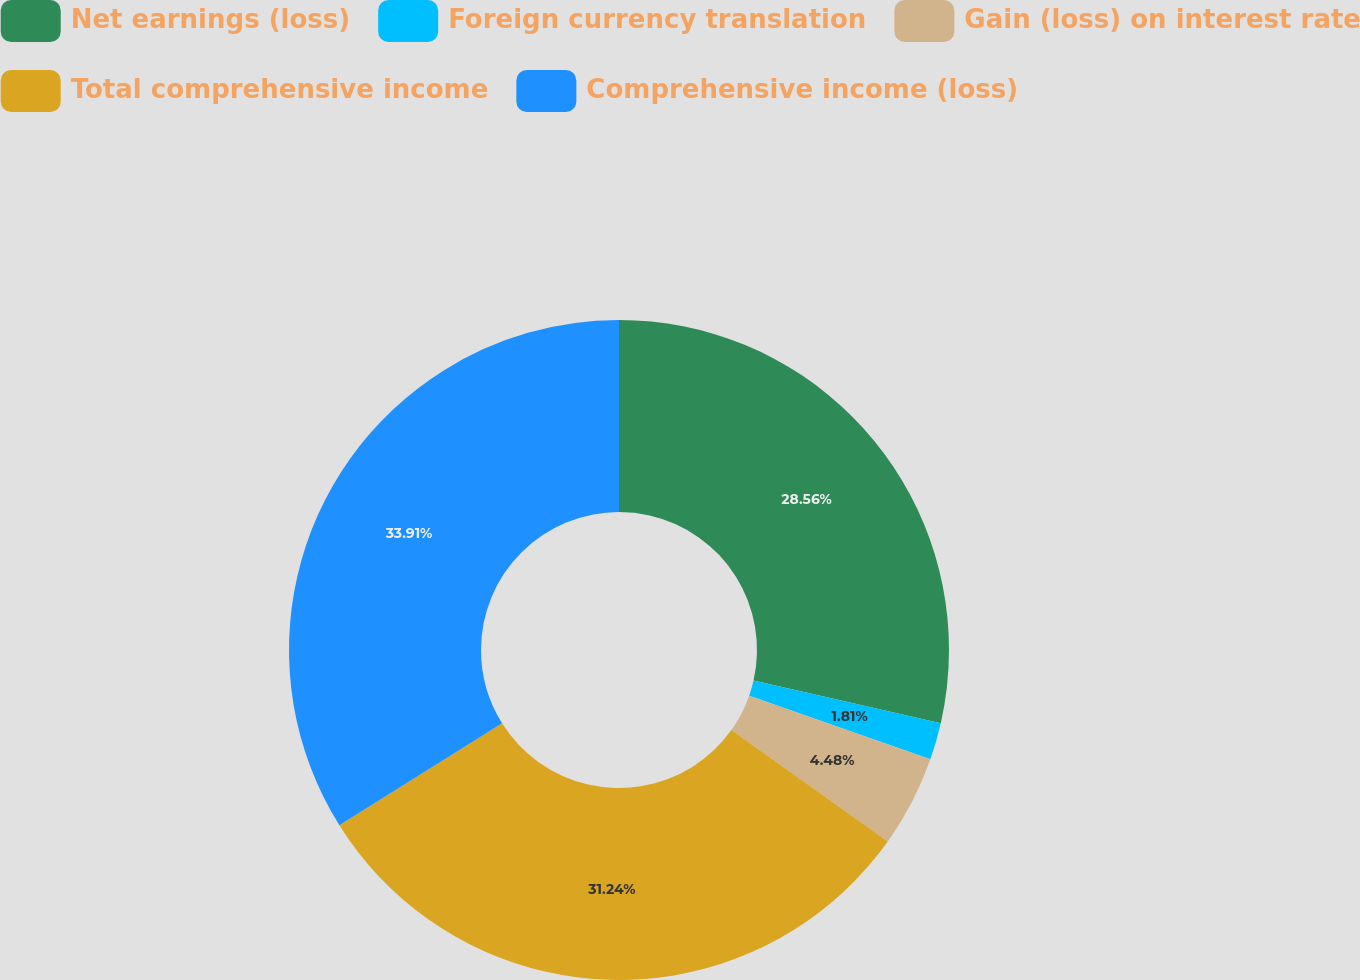Convert chart. <chart><loc_0><loc_0><loc_500><loc_500><pie_chart><fcel>Net earnings (loss)<fcel>Foreign currency translation<fcel>Gain (loss) on interest rate<fcel>Total comprehensive income<fcel>Comprehensive income (loss)<nl><fcel>28.56%<fcel>1.81%<fcel>4.48%<fcel>31.24%<fcel>33.91%<nl></chart> 